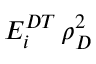Convert formula to latex. <formula><loc_0><loc_0><loc_500><loc_500>E _ { i } ^ { D T } \, \rho _ { D } ^ { 2 }</formula> 